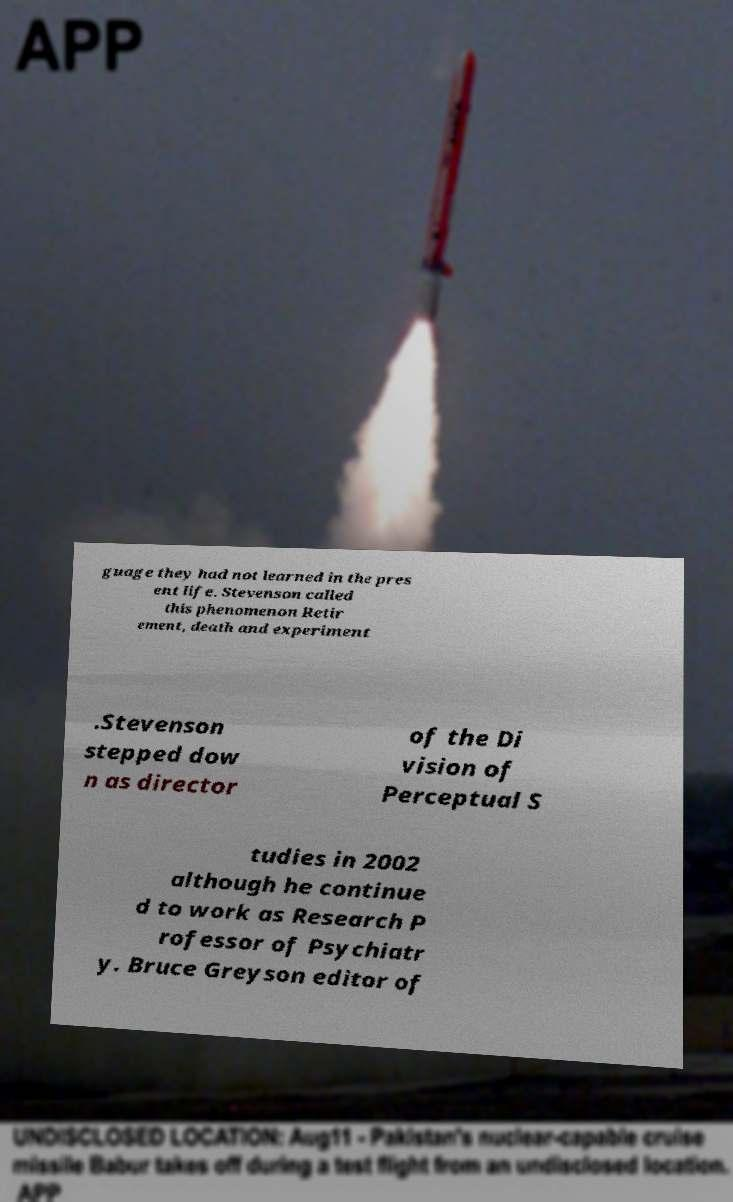I need the written content from this picture converted into text. Can you do that? guage they had not learned in the pres ent life. Stevenson called this phenomenon Retir ement, death and experiment .Stevenson stepped dow n as director of the Di vision of Perceptual S tudies in 2002 although he continue d to work as Research P rofessor of Psychiatr y. Bruce Greyson editor of 